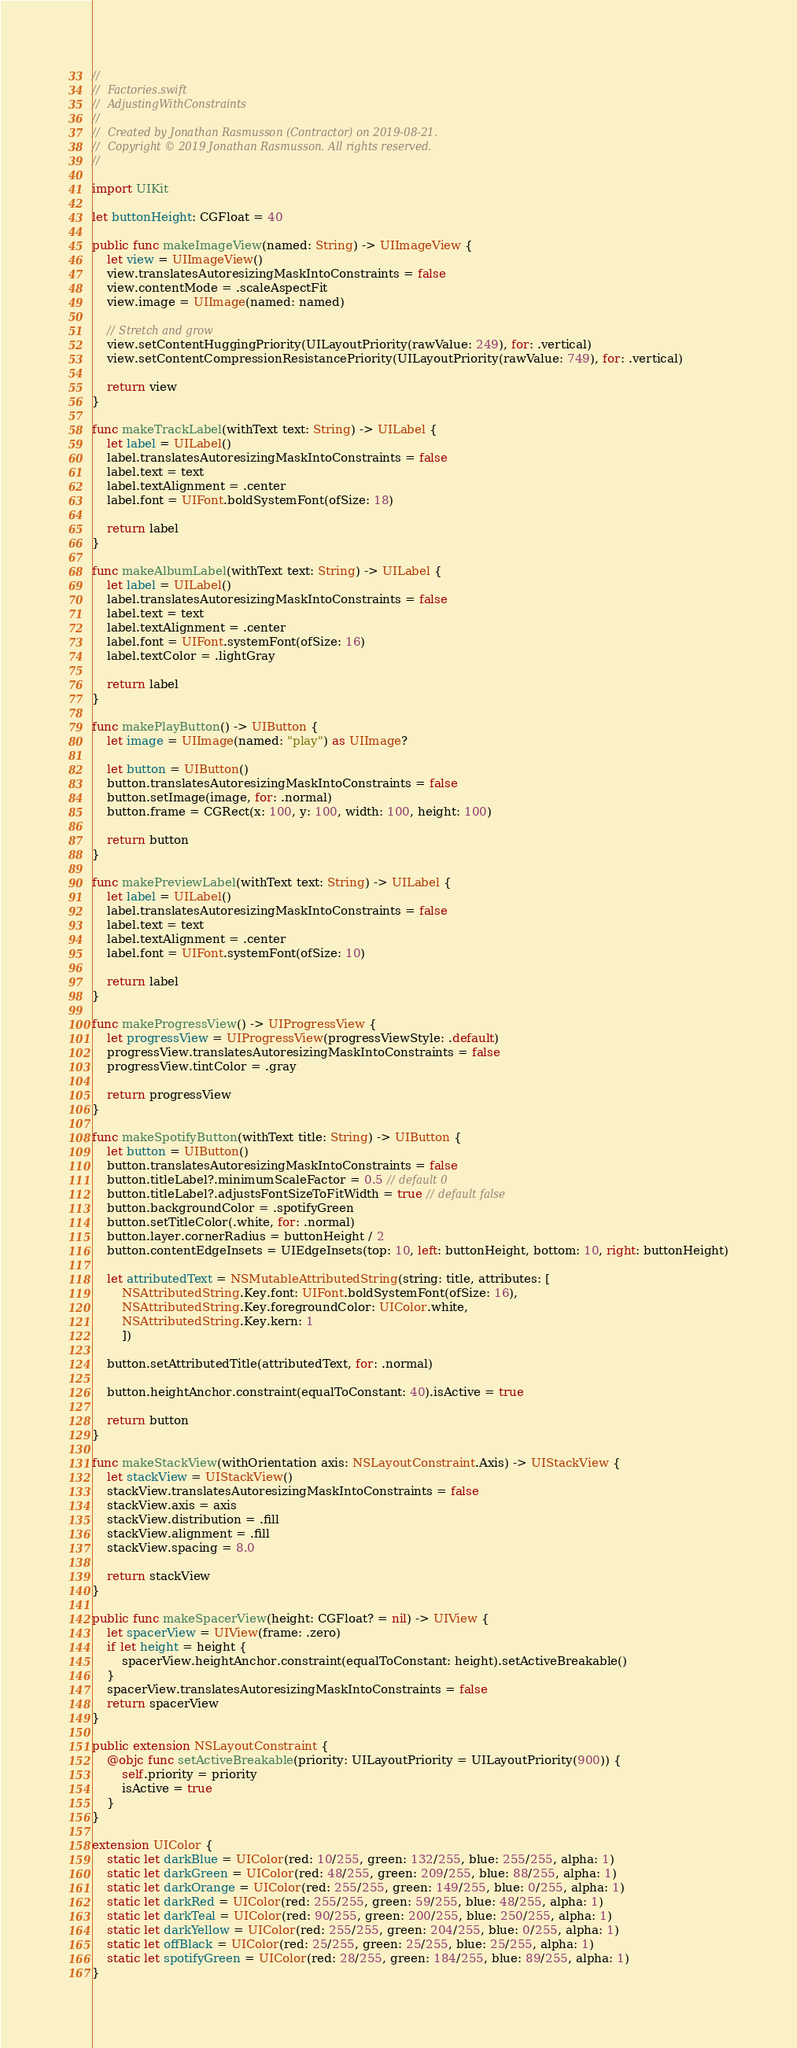Convert code to text. <code><loc_0><loc_0><loc_500><loc_500><_Swift_>//
//  Factories.swift
//  AdjustingWithConstraints
//
//  Created by Jonathan Rasmusson (Contractor) on 2019-08-21.
//  Copyright © 2019 Jonathan Rasmusson. All rights reserved.
//

import UIKit

let buttonHeight: CGFloat = 40

public func makeImageView(named: String) -> UIImageView {
    let view = UIImageView()
    view.translatesAutoresizingMaskIntoConstraints = false
    view.contentMode = .scaleAspectFit
    view.image = UIImage(named: named)

    // Stretch and grow
    view.setContentHuggingPriority(UILayoutPriority(rawValue: 249), for: .vertical)
    view.setContentCompressionResistancePriority(UILayoutPriority(rawValue: 749), for: .vertical)

    return view
}

func makeTrackLabel(withText text: String) -> UILabel {
    let label = UILabel()
    label.translatesAutoresizingMaskIntoConstraints = false
    label.text = text
    label.textAlignment = .center
    label.font = UIFont.boldSystemFont(ofSize: 18)

    return label
}

func makeAlbumLabel(withText text: String) -> UILabel {
    let label = UILabel()
    label.translatesAutoresizingMaskIntoConstraints = false
    label.text = text
    label.textAlignment = .center
    label.font = UIFont.systemFont(ofSize: 16)
    label.textColor = .lightGray

    return label
}

func makePlayButton() -> UIButton {
    let image = UIImage(named: "play") as UIImage?

    let button = UIButton()
    button.translatesAutoresizingMaskIntoConstraints = false
    button.setImage(image, for: .normal)
    button.frame = CGRect(x: 100, y: 100, width: 100, height: 100)

    return button
}

func makePreviewLabel(withText text: String) -> UILabel {
    let label = UILabel()
    label.translatesAutoresizingMaskIntoConstraints = false
    label.text = text
    label.textAlignment = .center
    label.font = UIFont.systemFont(ofSize: 10)

    return label
}

func makeProgressView() -> UIProgressView {
    let progressView = UIProgressView(progressViewStyle: .default)
    progressView.translatesAutoresizingMaskIntoConstraints = false
    progressView.tintColor = .gray

    return progressView
}

func makeSpotifyButton(withText title: String) -> UIButton {
    let button = UIButton()
    button.translatesAutoresizingMaskIntoConstraints = false
    button.titleLabel?.minimumScaleFactor = 0.5 // default 0
    button.titleLabel?.adjustsFontSizeToFitWidth = true // default false
    button.backgroundColor = .spotifyGreen
    button.setTitleColor(.white, for: .normal)
    button.layer.cornerRadius = buttonHeight / 2
    button.contentEdgeInsets = UIEdgeInsets(top: 10, left: buttonHeight, bottom: 10, right: buttonHeight)

    let attributedText = NSMutableAttributedString(string: title, attributes: [
        NSAttributedString.Key.font: UIFont.boldSystemFont(ofSize: 16),
        NSAttributedString.Key.foregroundColor: UIColor.white,
        NSAttributedString.Key.kern: 1
        ])

    button.setAttributedTitle(attributedText, for: .normal)

    button.heightAnchor.constraint(equalToConstant: 40).isActive = true

    return button
}

func makeStackView(withOrientation axis: NSLayoutConstraint.Axis) -> UIStackView {
    let stackView = UIStackView()
    stackView.translatesAutoresizingMaskIntoConstraints = false
    stackView.axis = axis
    stackView.distribution = .fill
    stackView.alignment = .fill
    stackView.spacing = 8.0

    return stackView
}

public func makeSpacerView(height: CGFloat? = nil) -> UIView {
    let spacerView = UIView(frame: .zero)
    if let height = height {
        spacerView.heightAnchor.constraint(equalToConstant: height).setActiveBreakable()
    }
    spacerView.translatesAutoresizingMaskIntoConstraints = false
    return spacerView
}

public extension NSLayoutConstraint {
    @objc func setActiveBreakable(priority: UILayoutPriority = UILayoutPriority(900)) {
        self.priority = priority
        isActive = true
    }
}

extension UIColor {
    static let darkBlue = UIColor(red: 10/255, green: 132/255, blue: 255/255, alpha: 1)
    static let darkGreen = UIColor(red: 48/255, green: 209/255, blue: 88/255, alpha: 1)
    static let darkOrange = UIColor(red: 255/255, green: 149/255, blue: 0/255, alpha: 1)
    static let darkRed = UIColor(red: 255/255, green: 59/255, blue: 48/255, alpha: 1)
    static let darkTeal = UIColor(red: 90/255, green: 200/255, blue: 250/255, alpha: 1)
    static let darkYellow = UIColor(red: 255/255, green: 204/255, blue: 0/255, alpha: 1)
    static let offBlack = UIColor(red: 25/255, green: 25/255, blue: 25/255, alpha: 1)
    static let spotifyGreen = UIColor(red: 28/255, green: 184/255, blue: 89/255, alpha: 1)
}

</code> 